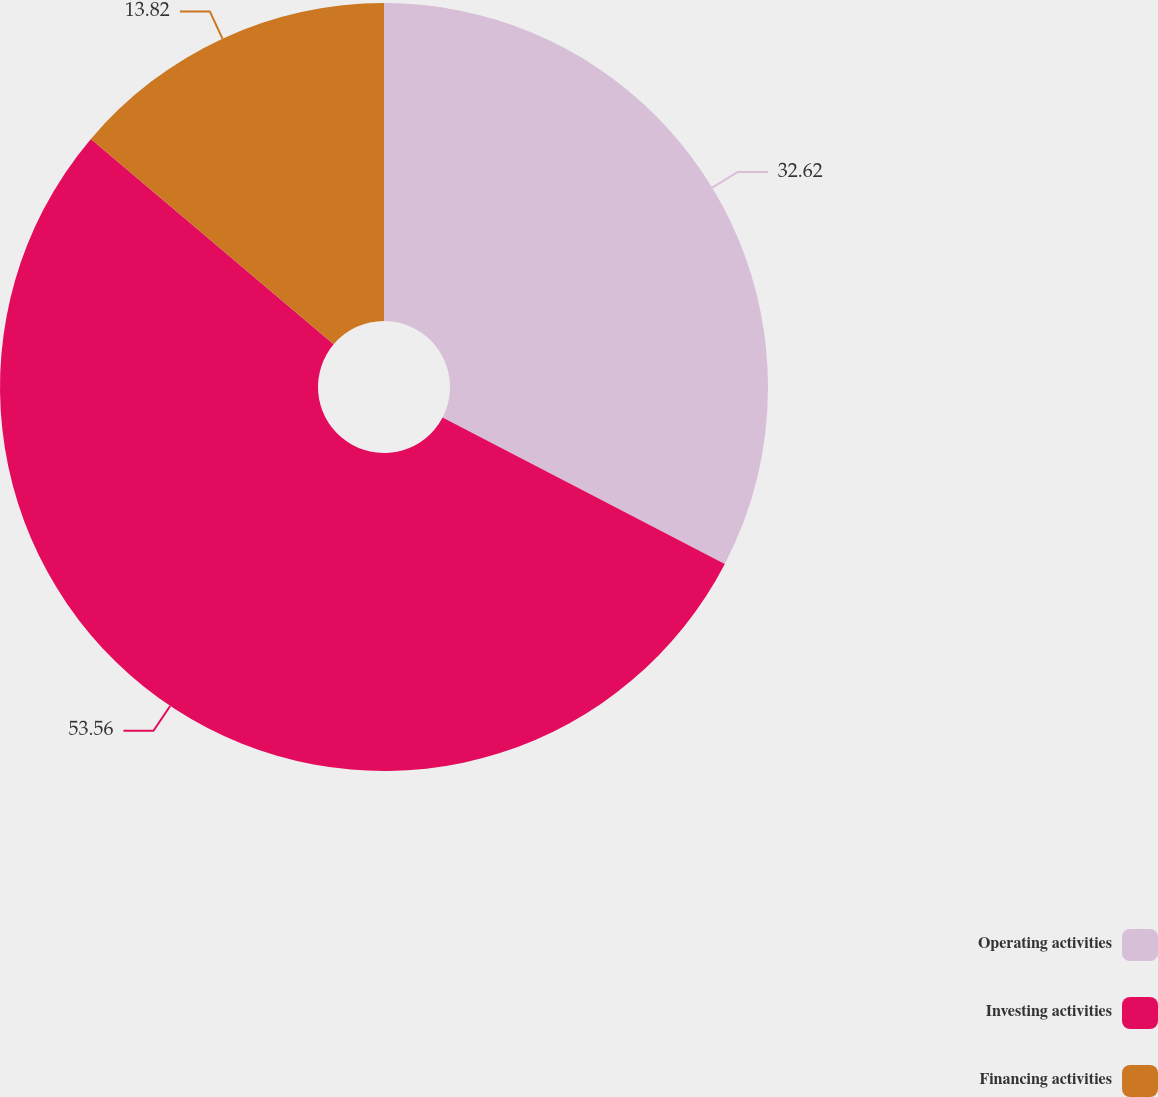<chart> <loc_0><loc_0><loc_500><loc_500><pie_chart><fcel>Operating activities<fcel>Investing activities<fcel>Financing activities<nl><fcel>32.62%<fcel>53.56%<fcel>13.82%<nl></chart> 